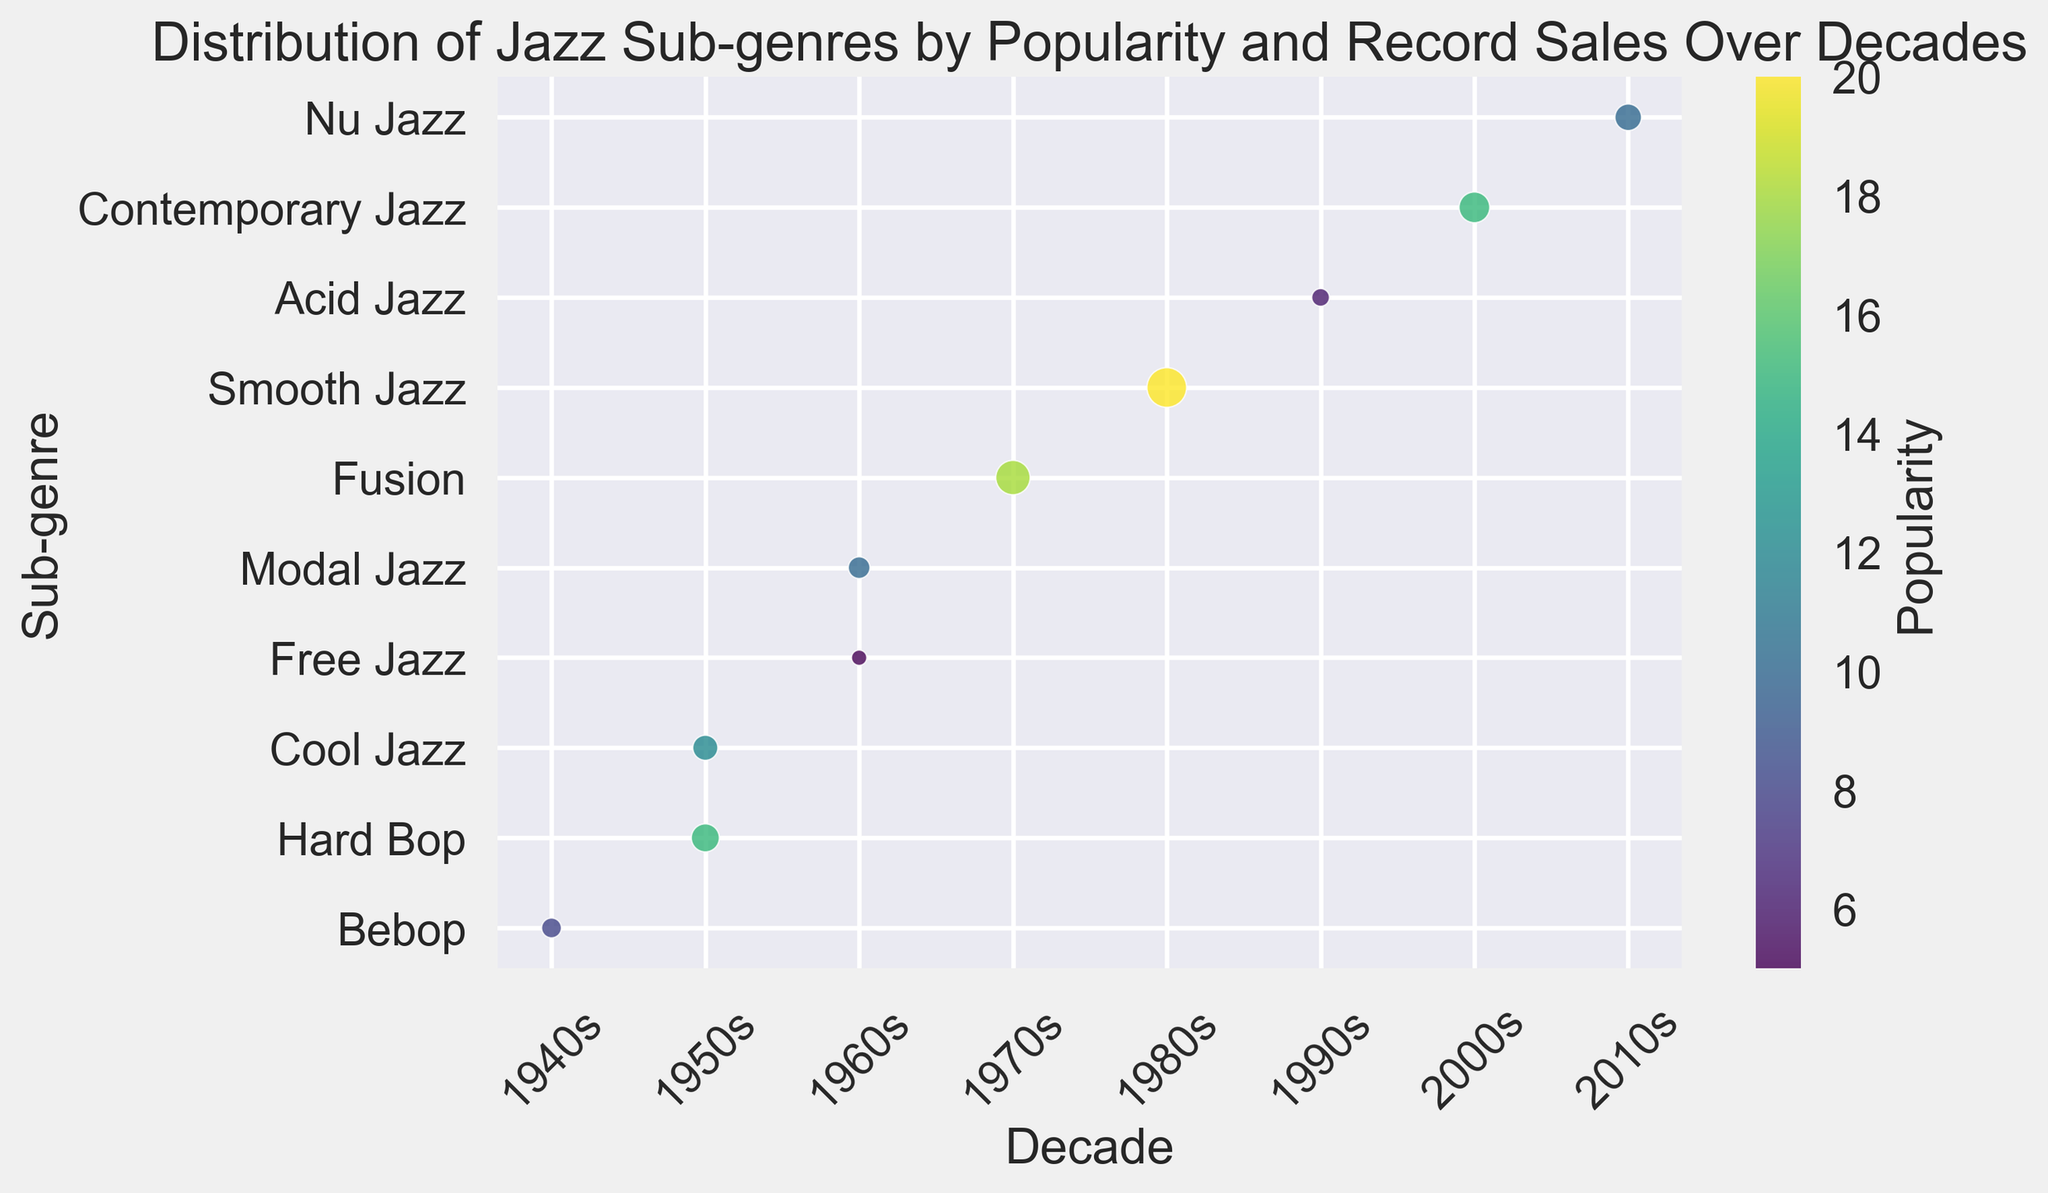What decade had the highest number of popular jazz sub-genres represented? Look at the 'Decade' column and identify which decade has the most different 'Sub-genre' entries.
Answer: 1950s Which sub-genre had the highest record sales, and in which decade did it occur? Look at the bubble sizes to identify the largest bubble, and check its corresponding 'Sub-genre' and 'Decade'.
Answer: Smooth Jazz in the 1980s How does the popularity of Cool Jazz in the 1950s compare to the popularity of Modal Jazz in the 1960s? Compare the color intensity of the bubbles corresponding to Cool Jazz in the 1950s and Modal Jazz in the 1960s.
Answer: Cool Jazz is more popular What is the average record sales for the sub-genres in the 2000s? Identify the sub-genres in the 2000s and calculate the average of their record sales: Contemporary Jazz (1200000).
Answer: 1200000 Which decade saw the least popular jazz sub-genre and what is that sub-genre? Find the sub-genre with the least intensity in the color scheme (least popular) and check its corresponding decade.
Answer: Free Jazz in the 1960s Compare the record sales between Hard Bop in the 1950s and Bebop in the 1940s. Which sub-genre had more record sales and by how much? Look at the bubble sizes and corresponding record sales for Hard Bop in the 1950s and Bebop in the 1940s. Subtract the smaller sales figures from the larger sales figure.
Answer: Hard Bop had 500,000 more record sales What is the total record sales for the sub-genres represented in the 1960s? Identify the sub-genres in the 1960s and sum their record sales: Free Jazz (300000) + Modal Jazz (600000).
Answer: 900000 Which sub-genre had popularity of 10 in the 2010s and what were its approximate record sales? Find the sub-genre in the 2010s with the color intensity representing a popularity of 10 and note its bubble size for record sales.
Answer: Nu Jazz with 900,000 record sales Are the record sales for Bebop in the 1940s greater than for Acid Jazz in the 1990s? Compare the bubble sizes for Bebop in the 1940s and Acid Jazz in the 1990s to see which is larger.
Answer: No 